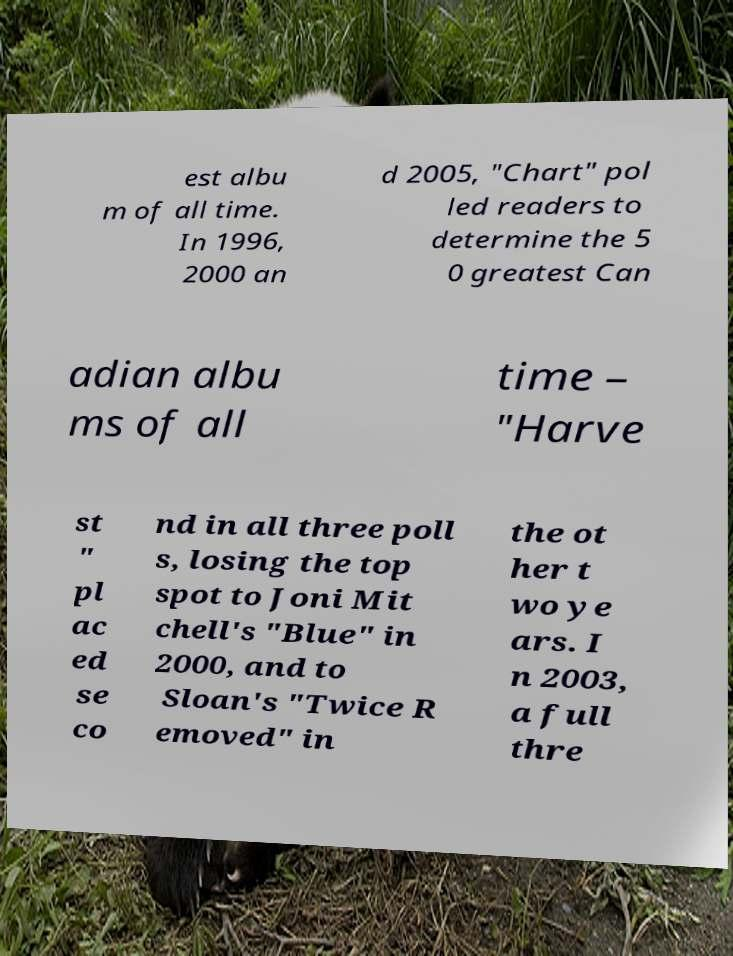For documentation purposes, I need the text within this image transcribed. Could you provide that? est albu m of all time. In 1996, 2000 an d 2005, "Chart" pol led readers to determine the 5 0 greatest Can adian albu ms of all time – "Harve st " pl ac ed se co nd in all three poll s, losing the top spot to Joni Mit chell's "Blue" in 2000, and to Sloan's "Twice R emoved" in the ot her t wo ye ars. I n 2003, a full thre 